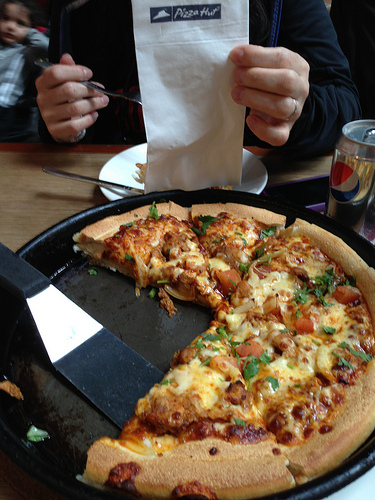Please provide the bounding box coordinate of the region this sentence describes: Pizza Hut logo on napkin. The Pizza Hut logo on the napkin is located at coordinates [0.42, 0.0, 0.6, 0.06]. 